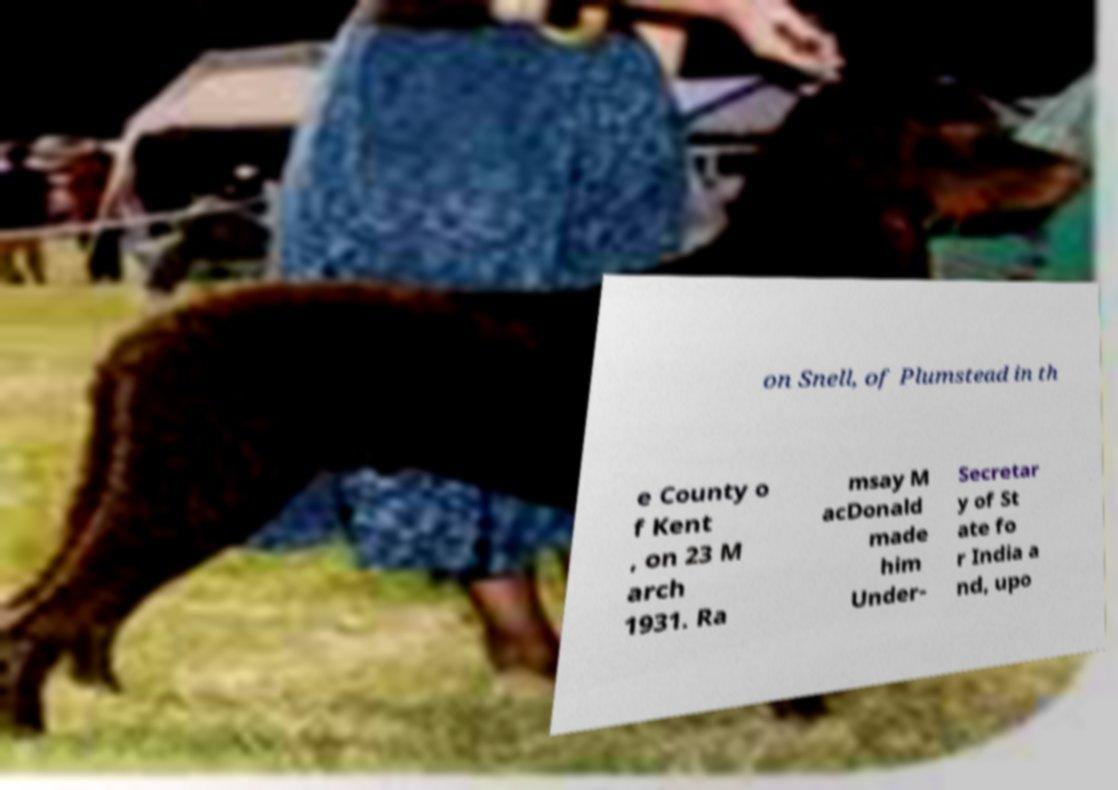Please identify and transcribe the text found in this image. on Snell, of Plumstead in th e County o f Kent , on 23 M arch 1931. Ra msay M acDonald made him Under- Secretar y of St ate fo r India a nd, upo 